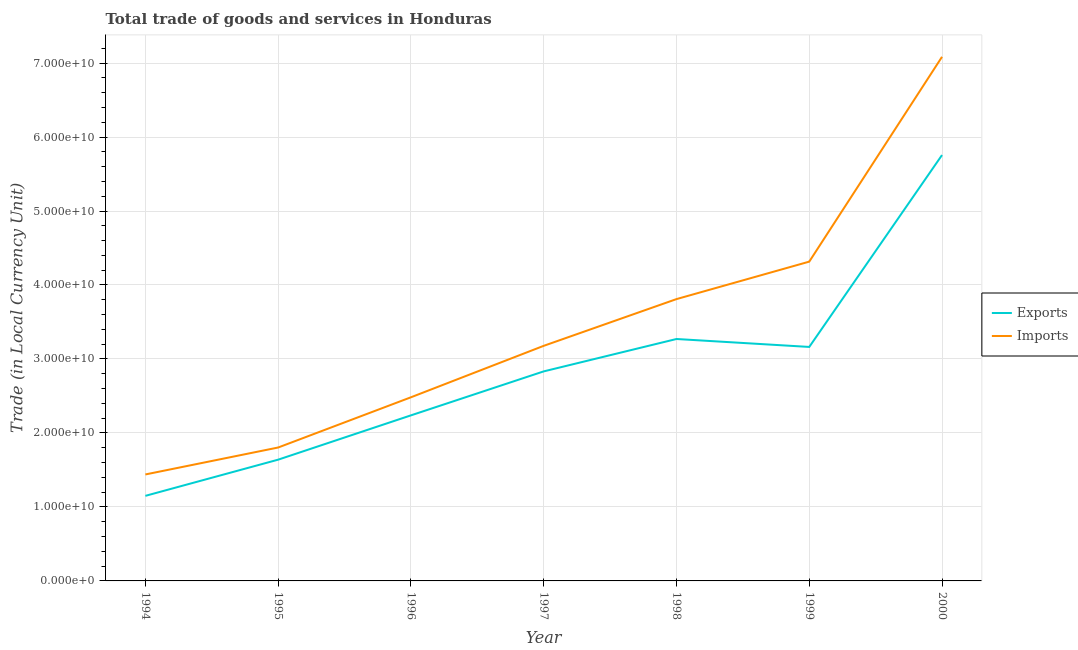How many different coloured lines are there?
Offer a terse response. 2. Is the number of lines equal to the number of legend labels?
Keep it short and to the point. Yes. What is the export of goods and services in 1994?
Your response must be concise. 1.15e+1. Across all years, what is the maximum export of goods and services?
Provide a short and direct response. 5.76e+1. Across all years, what is the minimum imports of goods and services?
Ensure brevity in your answer.  1.44e+1. In which year was the export of goods and services maximum?
Offer a terse response. 2000. What is the total imports of goods and services in the graph?
Your answer should be very brief. 2.41e+11. What is the difference between the imports of goods and services in 1996 and that in 1998?
Offer a very short reply. -1.33e+1. What is the difference between the imports of goods and services in 1994 and the export of goods and services in 1998?
Offer a very short reply. -1.83e+1. What is the average imports of goods and services per year?
Offer a terse response. 3.44e+1. In the year 2000, what is the difference between the export of goods and services and imports of goods and services?
Provide a short and direct response. -1.33e+1. What is the ratio of the export of goods and services in 1995 to that in 1999?
Provide a succinct answer. 0.52. What is the difference between the highest and the second highest imports of goods and services?
Your answer should be compact. 2.77e+1. What is the difference between the highest and the lowest export of goods and services?
Provide a succinct answer. 4.61e+1. Is the sum of the imports of goods and services in 1997 and 1999 greater than the maximum export of goods and services across all years?
Ensure brevity in your answer.  Yes. Does the imports of goods and services monotonically increase over the years?
Provide a short and direct response. Yes. How many years are there in the graph?
Keep it short and to the point. 7. Are the values on the major ticks of Y-axis written in scientific E-notation?
Your response must be concise. Yes. Does the graph contain grids?
Offer a terse response. Yes. Where does the legend appear in the graph?
Provide a short and direct response. Center right. How are the legend labels stacked?
Make the answer very short. Vertical. What is the title of the graph?
Your response must be concise. Total trade of goods and services in Honduras. What is the label or title of the Y-axis?
Make the answer very short. Trade (in Local Currency Unit). What is the Trade (in Local Currency Unit) in Exports in 1994?
Your response must be concise. 1.15e+1. What is the Trade (in Local Currency Unit) of Imports in 1994?
Offer a very short reply. 1.44e+1. What is the Trade (in Local Currency Unit) of Exports in 1995?
Offer a very short reply. 1.64e+1. What is the Trade (in Local Currency Unit) in Imports in 1995?
Offer a very short reply. 1.80e+1. What is the Trade (in Local Currency Unit) of Exports in 1996?
Your response must be concise. 2.24e+1. What is the Trade (in Local Currency Unit) of Imports in 1996?
Your answer should be compact. 2.48e+1. What is the Trade (in Local Currency Unit) of Exports in 1997?
Make the answer very short. 2.83e+1. What is the Trade (in Local Currency Unit) of Imports in 1997?
Your response must be concise. 3.18e+1. What is the Trade (in Local Currency Unit) in Exports in 1998?
Give a very brief answer. 3.27e+1. What is the Trade (in Local Currency Unit) in Imports in 1998?
Keep it short and to the point. 3.81e+1. What is the Trade (in Local Currency Unit) of Exports in 1999?
Keep it short and to the point. 3.16e+1. What is the Trade (in Local Currency Unit) of Imports in 1999?
Offer a terse response. 4.32e+1. What is the Trade (in Local Currency Unit) of Exports in 2000?
Give a very brief answer. 5.76e+1. What is the Trade (in Local Currency Unit) in Imports in 2000?
Give a very brief answer. 7.08e+1. Across all years, what is the maximum Trade (in Local Currency Unit) of Exports?
Offer a very short reply. 5.76e+1. Across all years, what is the maximum Trade (in Local Currency Unit) of Imports?
Make the answer very short. 7.08e+1. Across all years, what is the minimum Trade (in Local Currency Unit) in Exports?
Your response must be concise. 1.15e+1. Across all years, what is the minimum Trade (in Local Currency Unit) in Imports?
Your response must be concise. 1.44e+1. What is the total Trade (in Local Currency Unit) of Exports in the graph?
Give a very brief answer. 2.00e+11. What is the total Trade (in Local Currency Unit) in Imports in the graph?
Provide a short and direct response. 2.41e+11. What is the difference between the Trade (in Local Currency Unit) in Exports in 1994 and that in 1995?
Ensure brevity in your answer.  -4.89e+09. What is the difference between the Trade (in Local Currency Unit) in Imports in 1994 and that in 1995?
Offer a very short reply. -3.64e+09. What is the difference between the Trade (in Local Currency Unit) of Exports in 1994 and that in 1996?
Provide a succinct answer. -1.09e+1. What is the difference between the Trade (in Local Currency Unit) of Imports in 1994 and that in 1996?
Give a very brief answer. -1.04e+1. What is the difference between the Trade (in Local Currency Unit) of Exports in 1994 and that in 1997?
Your response must be concise. -1.68e+1. What is the difference between the Trade (in Local Currency Unit) of Imports in 1994 and that in 1997?
Offer a terse response. -1.74e+1. What is the difference between the Trade (in Local Currency Unit) of Exports in 1994 and that in 1998?
Provide a short and direct response. -2.12e+1. What is the difference between the Trade (in Local Currency Unit) of Imports in 1994 and that in 1998?
Your answer should be very brief. -2.37e+1. What is the difference between the Trade (in Local Currency Unit) in Exports in 1994 and that in 1999?
Ensure brevity in your answer.  -2.01e+1. What is the difference between the Trade (in Local Currency Unit) of Imports in 1994 and that in 1999?
Offer a very short reply. -2.88e+1. What is the difference between the Trade (in Local Currency Unit) of Exports in 1994 and that in 2000?
Provide a short and direct response. -4.61e+1. What is the difference between the Trade (in Local Currency Unit) of Imports in 1994 and that in 2000?
Provide a succinct answer. -5.64e+1. What is the difference between the Trade (in Local Currency Unit) of Exports in 1995 and that in 1996?
Your answer should be very brief. -5.99e+09. What is the difference between the Trade (in Local Currency Unit) in Imports in 1995 and that in 1996?
Your answer should be compact. -6.79e+09. What is the difference between the Trade (in Local Currency Unit) in Exports in 1995 and that in 1997?
Provide a succinct answer. -1.19e+1. What is the difference between the Trade (in Local Currency Unit) in Imports in 1995 and that in 1997?
Offer a terse response. -1.37e+1. What is the difference between the Trade (in Local Currency Unit) in Exports in 1995 and that in 1998?
Keep it short and to the point. -1.63e+1. What is the difference between the Trade (in Local Currency Unit) of Imports in 1995 and that in 1998?
Provide a short and direct response. -2.01e+1. What is the difference between the Trade (in Local Currency Unit) of Exports in 1995 and that in 1999?
Offer a very short reply. -1.52e+1. What is the difference between the Trade (in Local Currency Unit) of Imports in 1995 and that in 1999?
Make the answer very short. -2.51e+1. What is the difference between the Trade (in Local Currency Unit) in Exports in 1995 and that in 2000?
Provide a short and direct response. -4.12e+1. What is the difference between the Trade (in Local Currency Unit) of Imports in 1995 and that in 2000?
Make the answer very short. -5.28e+1. What is the difference between the Trade (in Local Currency Unit) of Exports in 1996 and that in 1997?
Provide a succinct answer. -5.94e+09. What is the difference between the Trade (in Local Currency Unit) of Imports in 1996 and that in 1997?
Your answer should be compact. -6.95e+09. What is the difference between the Trade (in Local Currency Unit) in Exports in 1996 and that in 1998?
Offer a very short reply. -1.03e+1. What is the difference between the Trade (in Local Currency Unit) in Imports in 1996 and that in 1998?
Provide a short and direct response. -1.33e+1. What is the difference between the Trade (in Local Currency Unit) in Exports in 1996 and that in 1999?
Give a very brief answer. -9.25e+09. What is the difference between the Trade (in Local Currency Unit) in Imports in 1996 and that in 1999?
Your response must be concise. -1.83e+1. What is the difference between the Trade (in Local Currency Unit) of Exports in 1996 and that in 2000?
Your response must be concise. -3.52e+1. What is the difference between the Trade (in Local Currency Unit) in Imports in 1996 and that in 2000?
Your answer should be compact. -4.60e+1. What is the difference between the Trade (in Local Currency Unit) of Exports in 1997 and that in 1998?
Your response must be concise. -4.38e+09. What is the difference between the Trade (in Local Currency Unit) in Imports in 1997 and that in 1998?
Provide a short and direct response. -6.32e+09. What is the difference between the Trade (in Local Currency Unit) of Exports in 1997 and that in 1999?
Provide a succinct answer. -3.30e+09. What is the difference between the Trade (in Local Currency Unit) in Imports in 1997 and that in 1999?
Provide a succinct answer. -1.14e+1. What is the difference between the Trade (in Local Currency Unit) in Exports in 1997 and that in 2000?
Offer a terse response. -2.92e+1. What is the difference between the Trade (in Local Currency Unit) of Imports in 1997 and that in 2000?
Offer a very short reply. -3.91e+1. What is the difference between the Trade (in Local Currency Unit) of Exports in 1998 and that in 1999?
Your response must be concise. 1.07e+09. What is the difference between the Trade (in Local Currency Unit) of Imports in 1998 and that in 1999?
Provide a succinct answer. -5.06e+09. What is the difference between the Trade (in Local Currency Unit) of Exports in 1998 and that in 2000?
Your answer should be compact. -2.49e+1. What is the difference between the Trade (in Local Currency Unit) in Imports in 1998 and that in 2000?
Give a very brief answer. -3.27e+1. What is the difference between the Trade (in Local Currency Unit) of Exports in 1999 and that in 2000?
Keep it short and to the point. -2.59e+1. What is the difference between the Trade (in Local Currency Unit) of Imports in 1999 and that in 2000?
Offer a very short reply. -2.77e+1. What is the difference between the Trade (in Local Currency Unit) in Exports in 1994 and the Trade (in Local Currency Unit) in Imports in 1995?
Your response must be concise. -6.54e+09. What is the difference between the Trade (in Local Currency Unit) of Exports in 1994 and the Trade (in Local Currency Unit) of Imports in 1996?
Ensure brevity in your answer.  -1.33e+1. What is the difference between the Trade (in Local Currency Unit) in Exports in 1994 and the Trade (in Local Currency Unit) in Imports in 1997?
Offer a very short reply. -2.03e+1. What is the difference between the Trade (in Local Currency Unit) of Exports in 1994 and the Trade (in Local Currency Unit) of Imports in 1998?
Keep it short and to the point. -2.66e+1. What is the difference between the Trade (in Local Currency Unit) in Exports in 1994 and the Trade (in Local Currency Unit) in Imports in 1999?
Your answer should be compact. -3.17e+1. What is the difference between the Trade (in Local Currency Unit) of Exports in 1994 and the Trade (in Local Currency Unit) of Imports in 2000?
Offer a very short reply. -5.93e+1. What is the difference between the Trade (in Local Currency Unit) of Exports in 1995 and the Trade (in Local Currency Unit) of Imports in 1996?
Ensure brevity in your answer.  -8.43e+09. What is the difference between the Trade (in Local Currency Unit) of Exports in 1995 and the Trade (in Local Currency Unit) of Imports in 1997?
Your response must be concise. -1.54e+1. What is the difference between the Trade (in Local Currency Unit) of Exports in 1995 and the Trade (in Local Currency Unit) of Imports in 1998?
Offer a terse response. -2.17e+1. What is the difference between the Trade (in Local Currency Unit) in Exports in 1995 and the Trade (in Local Currency Unit) in Imports in 1999?
Your response must be concise. -2.68e+1. What is the difference between the Trade (in Local Currency Unit) of Exports in 1995 and the Trade (in Local Currency Unit) of Imports in 2000?
Ensure brevity in your answer.  -5.44e+1. What is the difference between the Trade (in Local Currency Unit) of Exports in 1996 and the Trade (in Local Currency Unit) of Imports in 1997?
Provide a succinct answer. -9.40e+09. What is the difference between the Trade (in Local Currency Unit) in Exports in 1996 and the Trade (in Local Currency Unit) in Imports in 1998?
Make the answer very short. -1.57e+1. What is the difference between the Trade (in Local Currency Unit) of Exports in 1996 and the Trade (in Local Currency Unit) of Imports in 1999?
Your answer should be very brief. -2.08e+1. What is the difference between the Trade (in Local Currency Unit) of Exports in 1996 and the Trade (in Local Currency Unit) of Imports in 2000?
Ensure brevity in your answer.  -4.85e+1. What is the difference between the Trade (in Local Currency Unit) of Exports in 1997 and the Trade (in Local Currency Unit) of Imports in 1998?
Offer a very short reply. -9.77e+09. What is the difference between the Trade (in Local Currency Unit) of Exports in 1997 and the Trade (in Local Currency Unit) of Imports in 1999?
Provide a short and direct response. -1.48e+1. What is the difference between the Trade (in Local Currency Unit) of Exports in 1997 and the Trade (in Local Currency Unit) of Imports in 2000?
Offer a very short reply. -4.25e+1. What is the difference between the Trade (in Local Currency Unit) in Exports in 1998 and the Trade (in Local Currency Unit) in Imports in 1999?
Provide a short and direct response. -1.05e+1. What is the difference between the Trade (in Local Currency Unit) in Exports in 1998 and the Trade (in Local Currency Unit) in Imports in 2000?
Offer a very short reply. -3.81e+1. What is the difference between the Trade (in Local Currency Unit) in Exports in 1999 and the Trade (in Local Currency Unit) in Imports in 2000?
Your answer should be very brief. -3.92e+1. What is the average Trade (in Local Currency Unit) in Exports per year?
Ensure brevity in your answer.  2.86e+1. What is the average Trade (in Local Currency Unit) of Imports per year?
Offer a very short reply. 3.44e+1. In the year 1994, what is the difference between the Trade (in Local Currency Unit) of Exports and Trade (in Local Currency Unit) of Imports?
Give a very brief answer. -2.89e+09. In the year 1995, what is the difference between the Trade (in Local Currency Unit) of Exports and Trade (in Local Currency Unit) of Imports?
Ensure brevity in your answer.  -1.64e+09. In the year 1996, what is the difference between the Trade (in Local Currency Unit) of Exports and Trade (in Local Currency Unit) of Imports?
Your answer should be very brief. -2.44e+09. In the year 1997, what is the difference between the Trade (in Local Currency Unit) in Exports and Trade (in Local Currency Unit) in Imports?
Give a very brief answer. -3.45e+09. In the year 1998, what is the difference between the Trade (in Local Currency Unit) of Exports and Trade (in Local Currency Unit) of Imports?
Provide a succinct answer. -5.39e+09. In the year 1999, what is the difference between the Trade (in Local Currency Unit) in Exports and Trade (in Local Currency Unit) in Imports?
Your response must be concise. -1.15e+1. In the year 2000, what is the difference between the Trade (in Local Currency Unit) of Exports and Trade (in Local Currency Unit) of Imports?
Your response must be concise. -1.33e+1. What is the ratio of the Trade (in Local Currency Unit) of Exports in 1994 to that in 1995?
Offer a terse response. 0.7. What is the ratio of the Trade (in Local Currency Unit) of Imports in 1994 to that in 1995?
Your answer should be compact. 0.8. What is the ratio of the Trade (in Local Currency Unit) of Exports in 1994 to that in 1996?
Make the answer very short. 0.51. What is the ratio of the Trade (in Local Currency Unit) of Imports in 1994 to that in 1996?
Provide a short and direct response. 0.58. What is the ratio of the Trade (in Local Currency Unit) in Exports in 1994 to that in 1997?
Your answer should be compact. 0.41. What is the ratio of the Trade (in Local Currency Unit) of Imports in 1994 to that in 1997?
Your answer should be very brief. 0.45. What is the ratio of the Trade (in Local Currency Unit) of Exports in 1994 to that in 1998?
Make the answer very short. 0.35. What is the ratio of the Trade (in Local Currency Unit) in Imports in 1994 to that in 1998?
Ensure brevity in your answer.  0.38. What is the ratio of the Trade (in Local Currency Unit) in Exports in 1994 to that in 1999?
Ensure brevity in your answer.  0.36. What is the ratio of the Trade (in Local Currency Unit) in Imports in 1994 to that in 1999?
Ensure brevity in your answer.  0.33. What is the ratio of the Trade (in Local Currency Unit) of Exports in 1994 to that in 2000?
Provide a succinct answer. 0.2. What is the ratio of the Trade (in Local Currency Unit) of Imports in 1994 to that in 2000?
Your answer should be compact. 0.2. What is the ratio of the Trade (in Local Currency Unit) in Exports in 1995 to that in 1996?
Your answer should be very brief. 0.73. What is the ratio of the Trade (in Local Currency Unit) of Imports in 1995 to that in 1996?
Keep it short and to the point. 0.73. What is the ratio of the Trade (in Local Currency Unit) in Exports in 1995 to that in 1997?
Your response must be concise. 0.58. What is the ratio of the Trade (in Local Currency Unit) of Imports in 1995 to that in 1997?
Offer a terse response. 0.57. What is the ratio of the Trade (in Local Currency Unit) in Exports in 1995 to that in 1998?
Make the answer very short. 0.5. What is the ratio of the Trade (in Local Currency Unit) of Imports in 1995 to that in 1998?
Provide a succinct answer. 0.47. What is the ratio of the Trade (in Local Currency Unit) of Exports in 1995 to that in 1999?
Your answer should be very brief. 0.52. What is the ratio of the Trade (in Local Currency Unit) in Imports in 1995 to that in 1999?
Your response must be concise. 0.42. What is the ratio of the Trade (in Local Currency Unit) of Exports in 1995 to that in 2000?
Give a very brief answer. 0.28. What is the ratio of the Trade (in Local Currency Unit) in Imports in 1995 to that in 2000?
Ensure brevity in your answer.  0.25. What is the ratio of the Trade (in Local Currency Unit) in Exports in 1996 to that in 1997?
Ensure brevity in your answer.  0.79. What is the ratio of the Trade (in Local Currency Unit) in Imports in 1996 to that in 1997?
Keep it short and to the point. 0.78. What is the ratio of the Trade (in Local Currency Unit) of Exports in 1996 to that in 1998?
Keep it short and to the point. 0.68. What is the ratio of the Trade (in Local Currency Unit) in Imports in 1996 to that in 1998?
Keep it short and to the point. 0.65. What is the ratio of the Trade (in Local Currency Unit) in Exports in 1996 to that in 1999?
Make the answer very short. 0.71. What is the ratio of the Trade (in Local Currency Unit) of Imports in 1996 to that in 1999?
Offer a very short reply. 0.58. What is the ratio of the Trade (in Local Currency Unit) in Exports in 1996 to that in 2000?
Offer a very short reply. 0.39. What is the ratio of the Trade (in Local Currency Unit) of Imports in 1996 to that in 2000?
Keep it short and to the point. 0.35. What is the ratio of the Trade (in Local Currency Unit) of Exports in 1997 to that in 1998?
Your answer should be compact. 0.87. What is the ratio of the Trade (in Local Currency Unit) in Imports in 1997 to that in 1998?
Your response must be concise. 0.83. What is the ratio of the Trade (in Local Currency Unit) in Exports in 1997 to that in 1999?
Your answer should be compact. 0.9. What is the ratio of the Trade (in Local Currency Unit) of Imports in 1997 to that in 1999?
Offer a terse response. 0.74. What is the ratio of the Trade (in Local Currency Unit) in Exports in 1997 to that in 2000?
Make the answer very short. 0.49. What is the ratio of the Trade (in Local Currency Unit) in Imports in 1997 to that in 2000?
Your answer should be very brief. 0.45. What is the ratio of the Trade (in Local Currency Unit) in Exports in 1998 to that in 1999?
Offer a terse response. 1.03. What is the ratio of the Trade (in Local Currency Unit) in Imports in 1998 to that in 1999?
Keep it short and to the point. 0.88. What is the ratio of the Trade (in Local Currency Unit) of Exports in 1998 to that in 2000?
Keep it short and to the point. 0.57. What is the ratio of the Trade (in Local Currency Unit) in Imports in 1998 to that in 2000?
Provide a succinct answer. 0.54. What is the ratio of the Trade (in Local Currency Unit) in Exports in 1999 to that in 2000?
Your answer should be very brief. 0.55. What is the ratio of the Trade (in Local Currency Unit) of Imports in 1999 to that in 2000?
Provide a short and direct response. 0.61. What is the difference between the highest and the second highest Trade (in Local Currency Unit) of Exports?
Make the answer very short. 2.49e+1. What is the difference between the highest and the second highest Trade (in Local Currency Unit) of Imports?
Offer a very short reply. 2.77e+1. What is the difference between the highest and the lowest Trade (in Local Currency Unit) in Exports?
Ensure brevity in your answer.  4.61e+1. What is the difference between the highest and the lowest Trade (in Local Currency Unit) in Imports?
Give a very brief answer. 5.64e+1. 